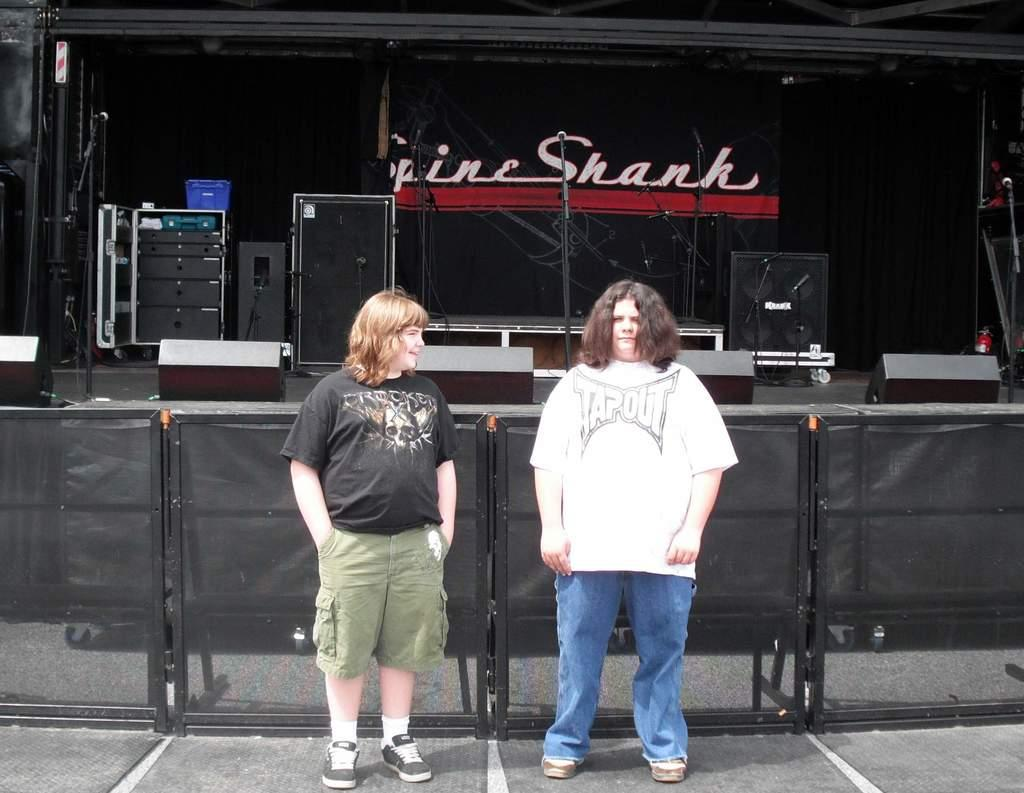How many people are in the image? There are two people standing in the image. What is the background of the image? The people are standing in front of a fence. What audio equipment is visible in the image? There are speakers and microphones visible in the image. Can you describe any other objects present in the image? There are other unspecified objects present in the image. What color is the shirt worn by the person driving in the image? There is no person driving in the image, as it features two people standing in front of a fence with audio equipment. What type of yarn is being used to create the microphone cables in the image? There is no information about the type of yarn used for the microphone cables, as the focus is on the presence of speakers and microphones in the image. 